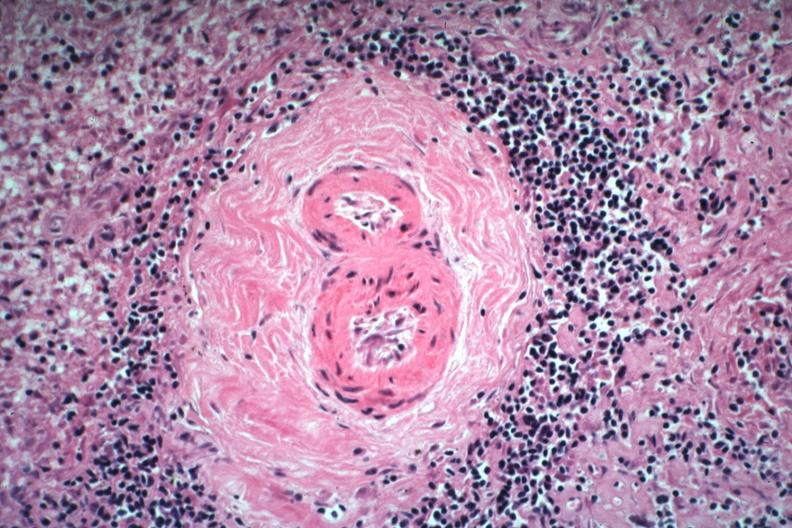what is present?
Answer the question using a single word or phrase. Lupus erythematosus periarterial fibrosis 